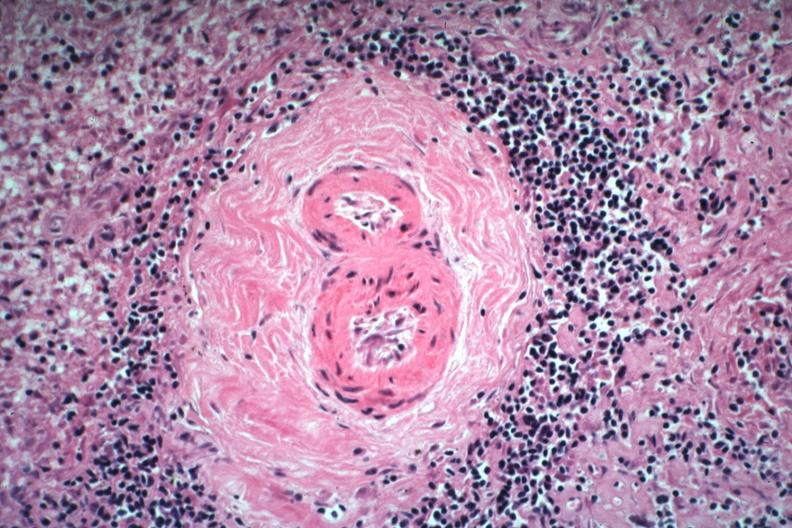what is present?
Answer the question using a single word or phrase. Lupus erythematosus periarterial fibrosis 